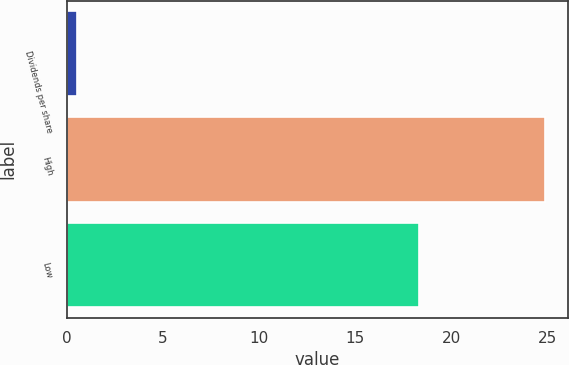Convert chart. <chart><loc_0><loc_0><loc_500><loc_500><bar_chart><fcel>Dividends per share<fcel>High<fcel>Low<nl><fcel>0.53<fcel>24.86<fcel>18.31<nl></chart> 